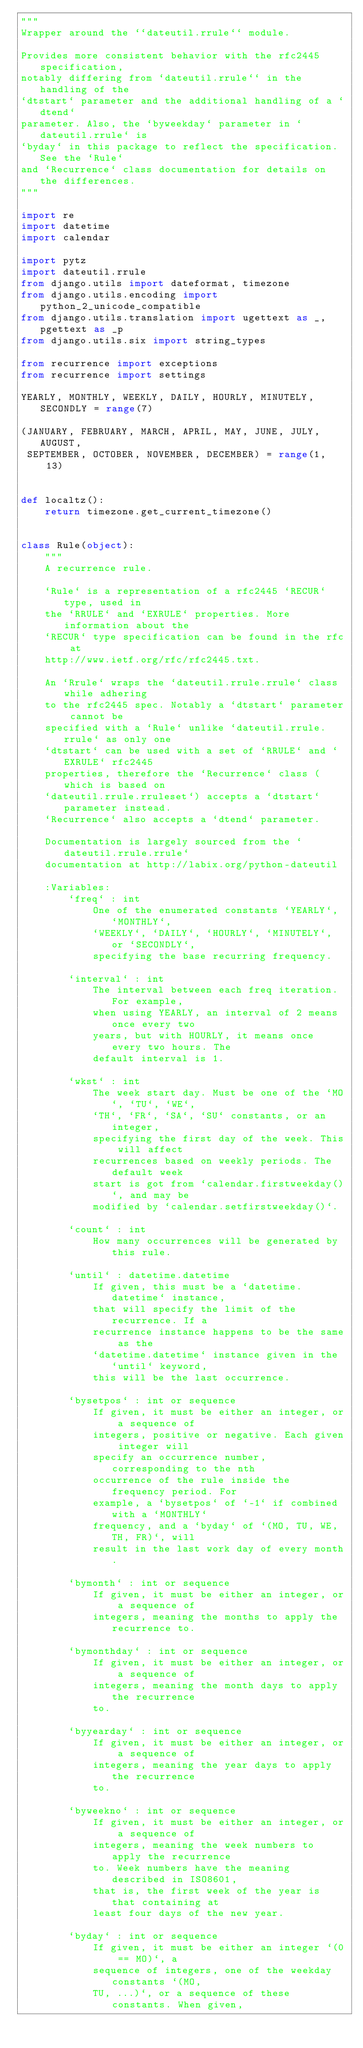Convert code to text. <code><loc_0><loc_0><loc_500><loc_500><_Python_>"""
Wrapper around the ``dateutil.rrule`` module.

Provides more consistent behavior with the rfc2445 specification,
notably differing from `dateutil.rrule`` in the handling of the
`dtstart` parameter and the additional handling of a `dtend`
parameter. Also, the `byweekday` parameter in `dateutil.rrule` is
`byday` in this package to reflect the specification. See the `Rule`
and `Recurrence` class documentation for details on the differences.
"""

import re
import datetime
import calendar

import pytz
import dateutil.rrule
from django.utils import dateformat, timezone
from django.utils.encoding import python_2_unicode_compatible
from django.utils.translation import ugettext as _, pgettext as _p
from django.utils.six import string_types

from recurrence import exceptions
from recurrence import settings

YEARLY, MONTHLY, WEEKLY, DAILY, HOURLY, MINUTELY, SECONDLY = range(7)

(JANUARY, FEBRUARY, MARCH, APRIL, MAY, JUNE, JULY, AUGUST,
 SEPTEMBER, OCTOBER, NOVEMBER, DECEMBER) = range(1, 13)


def localtz():
    return timezone.get_current_timezone()


class Rule(object):
    """
    A recurrence rule.

    `Rule` is a representation of a rfc2445 `RECUR` type, used in
    the `RRULE` and `EXRULE` properties. More information about the
    `RECUR` type specification can be found in the rfc at
    http://www.ietf.org/rfc/rfc2445.txt.

    An `Rrule` wraps the `dateutil.rrule.rrule` class while adhering
    to the rfc2445 spec. Notably a `dtstart` parameter cannot be
    specified with a `Rule` unlike `dateutil.rrule.rrule` as only one
    `dtstart` can be used with a set of `RRULE` and `EXRULE` rfc2445
    properties, therefore the `Recurrence` class (which is based on
    `dateutil.rrule.rruleset`) accepts a `dtstart` parameter instead.
    `Recurrence` also accepts a `dtend` parameter.

    Documentation is largely sourced from the `dateutil.rrule.rrule`
    documentation at http://labix.org/python-dateutil

    :Variables:
        `freq` : int
            One of the enumerated constants `YEARLY`, `MONTHLY`,
            `WEEKLY`, `DAILY`, `HOURLY`, `MINUTELY`, or `SECONDLY`,
            specifying the base recurring frequency.

        `interval` : int
            The interval between each freq iteration. For example,
            when using YEARLY, an interval of 2 means once every two
            years, but with HOURLY, it means once every two hours. The
            default interval is 1.

        `wkst` : int
            The week start day. Must be one of the `MO`, `TU`, `WE`,
            `TH`, `FR`, `SA`, `SU` constants, or an integer,
            specifying the first day of the week. This will affect
            recurrences based on weekly periods. The default week
            start is got from `calendar.firstweekday()`, and may be
            modified by `calendar.setfirstweekday()`.

        `count` : int
            How many occurrences will be generated by this rule.

        `until` : datetime.datetime
            If given, this must be a `datetime.datetime` instance,
            that will specify the limit of the recurrence. If a
            recurrence instance happens to be the same as the
            `datetime.datetime` instance given in the `until` keyword,
            this will be the last occurrence.

        `bysetpos` : int or sequence
            If given, it must be either an integer, or a sequence of
            integers, positive or negative. Each given integer will
            specify an occurrence number, corresponding to the nth
            occurrence of the rule inside the frequency period. For
            example, a `bysetpos` of `-1` if combined with a `MONTHLY`
            frequency, and a `byday` of `(MO, TU, WE, TH, FR)`, will
            result in the last work day of every month.

        `bymonth` : int or sequence
            If given, it must be either an integer, or a sequence of
            integers, meaning the months to apply the recurrence to.

        `bymonthday` : int or sequence
            If given, it must be either an integer, or a sequence of
            integers, meaning the month days to apply the recurrence
            to.

        `byyearday` : int or sequence
            If given, it must be either an integer, or a sequence of
            integers, meaning the year days to apply the recurrence
            to.

        `byweekno` : int or sequence
            If given, it must be either an integer, or a sequence of
            integers, meaning the week numbers to apply the recurrence
            to. Week numbers have the meaning described in ISO8601,
            that is, the first week of the year is that containing at
            least four days of the new year.

        `byday` : int or sequence
            If given, it must be either an integer `(0 == MO)`, a
            sequence of integers, one of the weekday constants `(MO,
            TU, ...)`, or a sequence of these constants. When given,</code> 